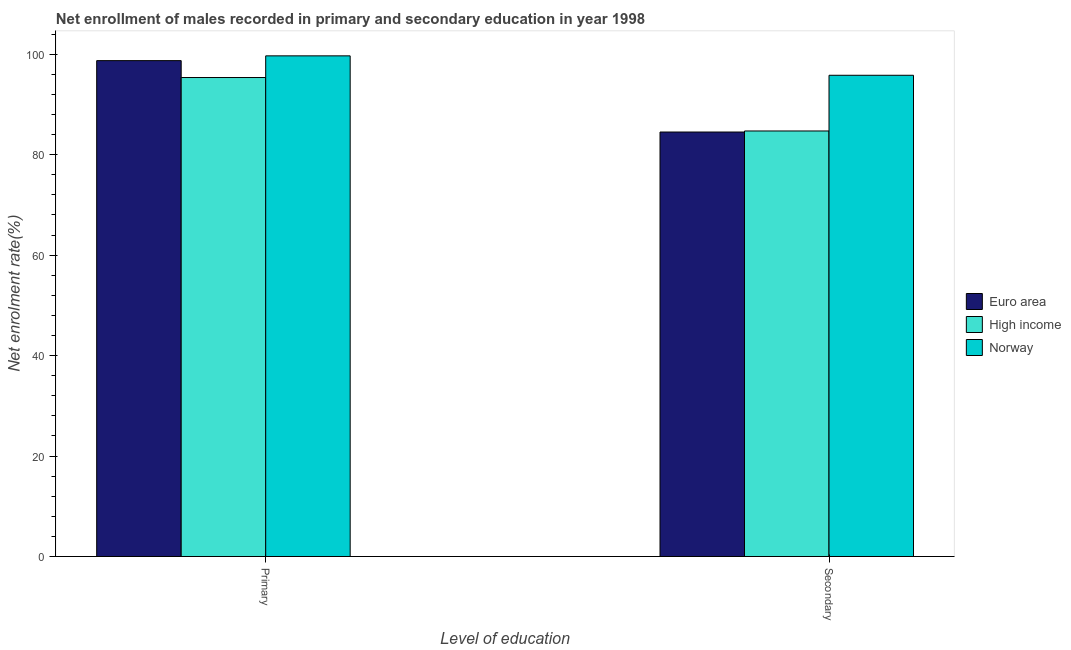How many different coloured bars are there?
Your answer should be compact. 3. How many groups of bars are there?
Provide a short and direct response. 2. Are the number of bars per tick equal to the number of legend labels?
Keep it short and to the point. Yes. How many bars are there on the 1st tick from the right?
Keep it short and to the point. 3. What is the label of the 2nd group of bars from the left?
Offer a terse response. Secondary. What is the enrollment rate in secondary education in Euro area?
Provide a succinct answer. 84.51. Across all countries, what is the maximum enrollment rate in primary education?
Provide a short and direct response. 99.68. Across all countries, what is the minimum enrollment rate in secondary education?
Ensure brevity in your answer.  84.51. In which country was the enrollment rate in secondary education maximum?
Provide a succinct answer. Norway. In which country was the enrollment rate in secondary education minimum?
Offer a terse response. Euro area. What is the total enrollment rate in primary education in the graph?
Your answer should be very brief. 293.77. What is the difference between the enrollment rate in primary education in Norway and that in High income?
Provide a succinct answer. 4.31. What is the difference between the enrollment rate in primary education in Norway and the enrollment rate in secondary education in Euro area?
Keep it short and to the point. 15.16. What is the average enrollment rate in secondary education per country?
Your response must be concise. 88.35. What is the difference between the enrollment rate in secondary education and enrollment rate in primary education in Euro area?
Provide a short and direct response. -14.21. What is the ratio of the enrollment rate in primary education in Euro area to that in High income?
Offer a very short reply. 1.04. In how many countries, is the enrollment rate in primary education greater than the average enrollment rate in primary education taken over all countries?
Give a very brief answer. 2. What does the 2nd bar from the right in Primary represents?
Make the answer very short. High income. Are the values on the major ticks of Y-axis written in scientific E-notation?
Make the answer very short. No. Where does the legend appear in the graph?
Keep it short and to the point. Center right. How many legend labels are there?
Provide a short and direct response. 3. How are the legend labels stacked?
Ensure brevity in your answer.  Vertical. What is the title of the graph?
Make the answer very short. Net enrollment of males recorded in primary and secondary education in year 1998. What is the label or title of the X-axis?
Offer a very short reply. Level of education. What is the label or title of the Y-axis?
Ensure brevity in your answer.  Net enrolment rate(%). What is the Net enrolment rate(%) of Euro area in Primary?
Keep it short and to the point. 98.73. What is the Net enrolment rate(%) in High income in Primary?
Your response must be concise. 95.37. What is the Net enrolment rate(%) in Norway in Primary?
Ensure brevity in your answer.  99.68. What is the Net enrolment rate(%) in Euro area in Secondary?
Ensure brevity in your answer.  84.51. What is the Net enrolment rate(%) in High income in Secondary?
Offer a very short reply. 84.72. What is the Net enrolment rate(%) in Norway in Secondary?
Provide a short and direct response. 95.81. Across all Level of education, what is the maximum Net enrolment rate(%) of Euro area?
Your response must be concise. 98.73. Across all Level of education, what is the maximum Net enrolment rate(%) in High income?
Offer a very short reply. 95.37. Across all Level of education, what is the maximum Net enrolment rate(%) in Norway?
Make the answer very short. 99.68. Across all Level of education, what is the minimum Net enrolment rate(%) of Euro area?
Keep it short and to the point. 84.51. Across all Level of education, what is the minimum Net enrolment rate(%) of High income?
Offer a terse response. 84.72. Across all Level of education, what is the minimum Net enrolment rate(%) of Norway?
Your answer should be very brief. 95.81. What is the total Net enrolment rate(%) of Euro area in the graph?
Offer a very short reply. 183.24. What is the total Net enrolment rate(%) in High income in the graph?
Provide a succinct answer. 180.09. What is the total Net enrolment rate(%) of Norway in the graph?
Provide a succinct answer. 195.49. What is the difference between the Net enrolment rate(%) in Euro area in Primary and that in Secondary?
Offer a very short reply. 14.21. What is the difference between the Net enrolment rate(%) in High income in Primary and that in Secondary?
Provide a short and direct response. 10.64. What is the difference between the Net enrolment rate(%) in Norway in Primary and that in Secondary?
Offer a terse response. 3.86. What is the difference between the Net enrolment rate(%) in Euro area in Primary and the Net enrolment rate(%) in High income in Secondary?
Make the answer very short. 14. What is the difference between the Net enrolment rate(%) in Euro area in Primary and the Net enrolment rate(%) in Norway in Secondary?
Make the answer very short. 2.91. What is the difference between the Net enrolment rate(%) of High income in Primary and the Net enrolment rate(%) of Norway in Secondary?
Make the answer very short. -0.45. What is the average Net enrolment rate(%) of Euro area per Level of education?
Make the answer very short. 91.62. What is the average Net enrolment rate(%) in High income per Level of education?
Ensure brevity in your answer.  90.04. What is the average Net enrolment rate(%) in Norway per Level of education?
Keep it short and to the point. 97.75. What is the difference between the Net enrolment rate(%) of Euro area and Net enrolment rate(%) of High income in Primary?
Your answer should be compact. 3.36. What is the difference between the Net enrolment rate(%) in Euro area and Net enrolment rate(%) in Norway in Primary?
Ensure brevity in your answer.  -0.95. What is the difference between the Net enrolment rate(%) of High income and Net enrolment rate(%) of Norway in Primary?
Your answer should be very brief. -4.31. What is the difference between the Net enrolment rate(%) in Euro area and Net enrolment rate(%) in High income in Secondary?
Your answer should be compact. -0.21. What is the difference between the Net enrolment rate(%) of Euro area and Net enrolment rate(%) of Norway in Secondary?
Ensure brevity in your answer.  -11.3. What is the difference between the Net enrolment rate(%) of High income and Net enrolment rate(%) of Norway in Secondary?
Ensure brevity in your answer.  -11.09. What is the ratio of the Net enrolment rate(%) of Euro area in Primary to that in Secondary?
Offer a terse response. 1.17. What is the ratio of the Net enrolment rate(%) of High income in Primary to that in Secondary?
Your answer should be very brief. 1.13. What is the ratio of the Net enrolment rate(%) in Norway in Primary to that in Secondary?
Give a very brief answer. 1.04. What is the difference between the highest and the second highest Net enrolment rate(%) in Euro area?
Keep it short and to the point. 14.21. What is the difference between the highest and the second highest Net enrolment rate(%) of High income?
Give a very brief answer. 10.64. What is the difference between the highest and the second highest Net enrolment rate(%) in Norway?
Your answer should be very brief. 3.86. What is the difference between the highest and the lowest Net enrolment rate(%) of Euro area?
Your answer should be compact. 14.21. What is the difference between the highest and the lowest Net enrolment rate(%) of High income?
Offer a very short reply. 10.64. What is the difference between the highest and the lowest Net enrolment rate(%) of Norway?
Your answer should be compact. 3.86. 